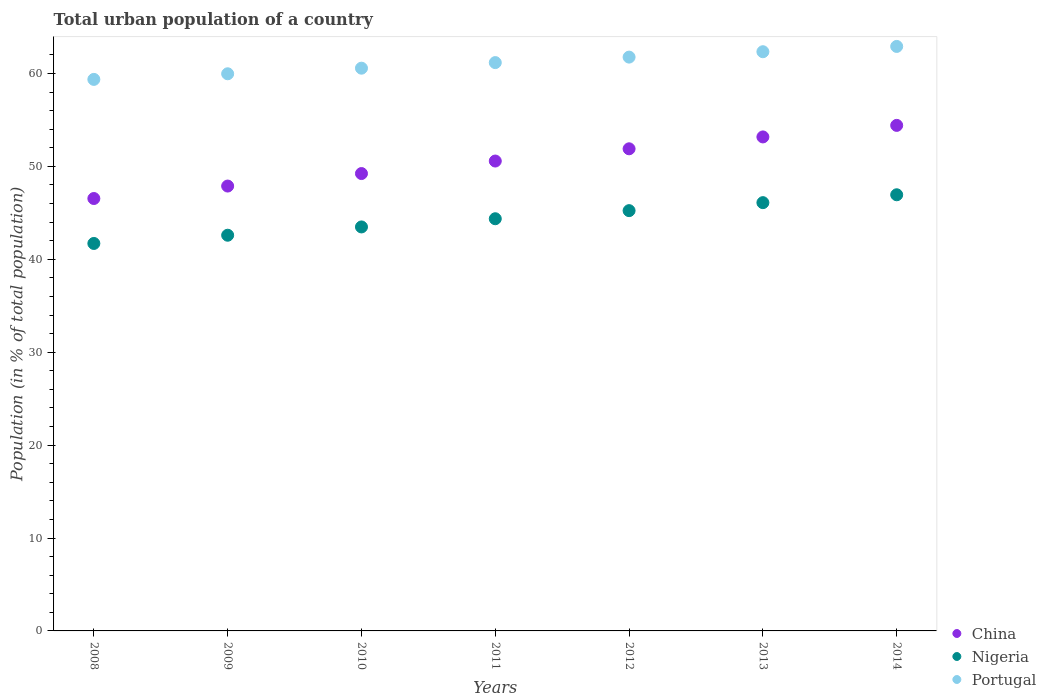How many different coloured dotlines are there?
Your answer should be compact. 3. What is the urban population in Nigeria in 2009?
Make the answer very short. 42.59. Across all years, what is the maximum urban population in China?
Offer a very short reply. 54.41. Across all years, what is the minimum urban population in Portugal?
Your response must be concise. 59.36. In which year was the urban population in Nigeria maximum?
Make the answer very short. 2014. In which year was the urban population in China minimum?
Provide a short and direct response. 2008. What is the total urban population in Portugal in the graph?
Your answer should be very brief. 428.06. What is the difference between the urban population in Portugal in 2009 and that in 2012?
Your response must be concise. -1.79. What is the difference between the urban population in Portugal in 2014 and the urban population in Nigeria in 2012?
Offer a very short reply. 17.67. What is the average urban population in China per year?
Give a very brief answer. 50.53. In the year 2008, what is the difference between the urban population in China and urban population in Portugal?
Your answer should be compact. -12.82. What is the ratio of the urban population in Nigeria in 2011 to that in 2012?
Ensure brevity in your answer.  0.98. What is the difference between the highest and the second highest urban population in Nigeria?
Make the answer very short. 0.85. What is the difference between the highest and the lowest urban population in Portugal?
Your answer should be very brief. 3.55. Is it the case that in every year, the sum of the urban population in Portugal and urban population in Nigeria  is greater than the urban population in China?
Ensure brevity in your answer.  Yes. Is the urban population in Portugal strictly less than the urban population in Nigeria over the years?
Your response must be concise. No. How many dotlines are there?
Offer a terse response. 3. How many years are there in the graph?
Keep it short and to the point. 7. What is the difference between two consecutive major ticks on the Y-axis?
Ensure brevity in your answer.  10. Are the values on the major ticks of Y-axis written in scientific E-notation?
Provide a short and direct response. No. Where does the legend appear in the graph?
Your answer should be compact. Bottom right. What is the title of the graph?
Make the answer very short. Total urban population of a country. Does "Kuwait" appear as one of the legend labels in the graph?
Your response must be concise. No. What is the label or title of the X-axis?
Offer a terse response. Years. What is the label or title of the Y-axis?
Your response must be concise. Population (in % of total population). What is the Population (in % of total population) of China in 2008?
Provide a succinct answer. 46.54. What is the Population (in % of total population) in Nigeria in 2008?
Provide a succinct answer. 41.7. What is the Population (in % of total population) of Portugal in 2008?
Keep it short and to the point. 59.36. What is the Population (in % of total population) of China in 2009?
Offer a very short reply. 47.88. What is the Population (in % of total population) in Nigeria in 2009?
Provide a succinct answer. 42.59. What is the Population (in % of total population) of Portugal in 2009?
Ensure brevity in your answer.  59.96. What is the Population (in % of total population) in China in 2010?
Your answer should be compact. 49.23. What is the Population (in % of total population) in Nigeria in 2010?
Your answer should be very brief. 43.48. What is the Population (in % of total population) of Portugal in 2010?
Your response must be concise. 60.57. What is the Population (in % of total population) in China in 2011?
Provide a short and direct response. 50.57. What is the Population (in % of total population) in Nigeria in 2011?
Offer a terse response. 44.36. What is the Population (in % of total population) in Portugal in 2011?
Your response must be concise. 61.17. What is the Population (in % of total population) of China in 2012?
Make the answer very short. 51.89. What is the Population (in % of total population) of Nigeria in 2012?
Ensure brevity in your answer.  45.23. What is the Population (in % of total population) of Portugal in 2012?
Provide a short and direct response. 61.76. What is the Population (in % of total population) of China in 2013?
Provide a short and direct response. 53.17. What is the Population (in % of total population) of Nigeria in 2013?
Give a very brief answer. 46.09. What is the Population (in % of total population) in Portugal in 2013?
Make the answer very short. 62.34. What is the Population (in % of total population) of China in 2014?
Offer a very short reply. 54.41. What is the Population (in % of total population) of Nigeria in 2014?
Offer a terse response. 46.94. What is the Population (in % of total population) in Portugal in 2014?
Provide a succinct answer. 62.91. Across all years, what is the maximum Population (in % of total population) in China?
Your answer should be compact. 54.41. Across all years, what is the maximum Population (in % of total population) of Nigeria?
Your answer should be compact. 46.94. Across all years, what is the maximum Population (in % of total population) in Portugal?
Offer a very short reply. 62.91. Across all years, what is the minimum Population (in % of total population) of China?
Your answer should be very brief. 46.54. Across all years, what is the minimum Population (in % of total population) of Nigeria?
Offer a terse response. 41.7. Across all years, what is the minimum Population (in % of total population) of Portugal?
Offer a very short reply. 59.36. What is the total Population (in % of total population) in China in the graph?
Your response must be concise. 353.69. What is the total Population (in % of total population) of Nigeria in the graph?
Your answer should be compact. 310.4. What is the total Population (in % of total population) of Portugal in the graph?
Offer a very short reply. 428.06. What is the difference between the Population (in % of total population) in China in 2008 and that in 2009?
Keep it short and to the point. -1.34. What is the difference between the Population (in % of total population) in Nigeria in 2008 and that in 2009?
Provide a succinct answer. -0.89. What is the difference between the Population (in % of total population) of Portugal in 2008 and that in 2009?
Provide a succinct answer. -0.6. What is the difference between the Population (in % of total population) of China in 2008 and that in 2010?
Provide a succinct answer. -2.69. What is the difference between the Population (in % of total population) of Nigeria in 2008 and that in 2010?
Keep it short and to the point. -1.78. What is the difference between the Population (in % of total population) of Portugal in 2008 and that in 2010?
Offer a very short reply. -1.21. What is the difference between the Population (in % of total population) in China in 2008 and that in 2011?
Offer a terse response. -4.03. What is the difference between the Population (in % of total population) in Nigeria in 2008 and that in 2011?
Offer a terse response. -2.66. What is the difference between the Population (in % of total population) in Portugal in 2008 and that in 2011?
Your answer should be compact. -1.81. What is the difference between the Population (in % of total population) of China in 2008 and that in 2012?
Provide a short and direct response. -5.35. What is the difference between the Population (in % of total population) of Nigeria in 2008 and that in 2012?
Make the answer very short. -3.53. What is the difference between the Population (in % of total population) of Portugal in 2008 and that in 2012?
Make the answer very short. -2.4. What is the difference between the Population (in % of total population) of China in 2008 and that in 2013?
Your response must be concise. -6.63. What is the difference between the Population (in % of total population) of Nigeria in 2008 and that in 2013?
Provide a succinct answer. -4.39. What is the difference between the Population (in % of total population) of Portugal in 2008 and that in 2013?
Make the answer very short. -2.98. What is the difference between the Population (in % of total population) in China in 2008 and that in 2014?
Provide a short and direct response. -7.87. What is the difference between the Population (in % of total population) in Nigeria in 2008 and that in 2014?
Provide a succinct answer. -5.24. What is the difference between the Population (in % of total population) in Portugal in 2008 and that in 2014?
Your answer should be very brief. -3.55. What is the difference between the Population (in % of total population) in China in 2009 and that in 2010?
Your response must be concise. -1.35. What is the difference between the Population (in % of total population) of Nigeria in 2009 and that in 2010?
Keep it short and to the point. -0.89. What is the difference between the Population (in % of total population) of Portugal in 2009 and that in 2010?
Provide a short and direct response. -0.6. What is the difference between the Population (in % of total population) of China in 2009 and that in 2011?
Offer a very short reply. -2.69. What is the difference between the Population (in % of total population) of Nigeria in 2009 and that in 2011?
Provide a succinct answer. -1.77. What is the difference between the Population (in % of total population) of Portugal in 2009 and that in 2011?
Offer a very short reply. -1.2. What is the difference between the Population (in % of total population) in China in 2009 and that in 2012?
Make the answer very short. -4.01. What is the difference between the Population (in % of total population) of Nigeria in 2009 and that in 2012?
Provide a succinct answer. -2.65. What is the difference between the Population (in % of total population) in Portugal in 2009 and that in 2012?
Offer a terse response. -1.79. What is the difference between the Population (in % of total population) in China in 2009 and that in 2013?
Your response must be concise. -5.29. What is the difference between the Population (in % of total population) of Nigeria in 2009 and that in 2013?
Offer a very short reply. -3.51. What is the difference between the Population (in % of total population) of Portugal in 2009 and that in 2013?
Your response must be concise. -2.37. What is the difference between the Population (in % of total population) of China in 2009 and that in 2014?
Your answer should be very brief. -6.53. What is the difference between the Population (in % of total population) in Nigeria in 2009 and that in 2014?
Make the answer very short. -4.35. What is the difference between the Population (in % of total population) of Portugal in 2009 and that in 2014?
Your answer should be compact. -2.94. What is the difference between the Population (in % of total population) of China in 2010 and that in 2011?
Your answer should be compact. -1.35. What is the difference between the Population (in % of total population) in Nigeria in 2010 and that in 2011?
Give a very brief answer. -0.88. What is the difference between the Population (in % of total population) of Portugal in 2010 and that in 2011?
Your response must be concise. -0.6. What is the difference between the Population (in % of total population) in China in 2010 and that in 2012?
Keep it short and to the point. -2.66. What is the difference between the Population (in % of total population) in Nigeria in 2010 and that in 2012?
Give a very brief answer. -1.75. What is the difference between the Population (in % of total population) in Portugal in 2010 and that in 2012?
Ensure brevity in your answer.  -1.19. What is the difference between the Population (in % of total population) in China in 2010 and that in 2013?
Your response must be concise. -3.94. What is the difference between the Population (in % of total population) in Nigeria in 2010 and that in 2013?
Make the answer very short. -2.61. What is the difference between the Population (in % of total population) of Portugal in 2010 and that in 2013?
Your response must be concise. -1.77. What is the difference between the Population (in % of total population) in China in 2010 and that in 2014?
Keep it short and to the point. -5.18. What is the difference between the Population (in % of total population) of Nigeria in 2010 and that in 2014?
Offer a terse response. -3.46. What is the difference between the Population (in % of total population) of Portugal in 2010 and that in 2014?
Provide a short and direct response. -2.34. What is the difference between the Population (in % of total population) in China in 2011 and that in 2012?
Your response must be concise. -1.32. What is the difference between the Population (in % of total population) in Nigeria in 2011 and that in 2012?
Make the answer very short. -0.87. What is the difference between the Population (in % of total population) of Portugal in 2011 and that in 2012?
Provide a succinct answer. -0.59. What is the difference between the Population (in % of total population) of China in 2011 and that in 2013?
Give a very brief answer. -2.6. What is the difference between the Population (in % of total population) in Nigeria in 2011 and that in 2013?
Ensure brevity in your answer.  -1.73. What is the difference between the Population (in % of total population) in Portugal in 2011 and that in 2013?
Your answer should be compact. -1.17. What is the difference between the Population (in % of total population) of China in 2011 and that in 2014?
Your answer should be compact. -3.84. What is the difference between the Population (in % of total population) in Nigeria in 2011 and that in 2014?
Offer a terse response. -2.58. What is the difference between the Population (in % of total population) in Portugal in 2011 and that in 2014?
Provide a succinct answer. -1.74. What is the difference between the Population (in % of total population) of China in 2012 and that in 2013?
Your response must be concise. -1.28. What is the difference between the Population (in % of total population) in Nigeria in 2012 and that in 2013?
Provide a succinct answer. -0.86. What is the difference between the Population (in % of total population) in Portugal in 2012 and that in 2013?
Your response must be concise. -0.58. What is the difference between the Population (in % of total population) of China in 2012 and that in 2014?
Make the answer very short. -2.52. What is the difference between the Population (in % of total population) in Nigeria in 2012 and that in 2014?
Ensure brevity in your answer.  -1.71. What is the difference between the Population (in % of total population) of Portugal in 2012 and that in 2014?
Your answer should be compact. -1.15. What is the difference between the Population (in % of total population) in China in 2013 and that in 2014?
Give a very brief answer. -1.24. What is the difference between the Population (in % of total population) in Nigeria in 2013 and that in 2014?
Give a very brief answer. -0.85. What is the difference between the Population (in % of total population) in Portugal in 2013 and that in 2014?
Offer a very short reply. -0.57. What is the difference between the Population (in % of total population) in China in 2008 and the Population (in % of total population) in Nigeria in 2009?
Provide a succinct answer. 3.95. What is the difference between the Population (in % of total population) of China in 2008 and the Population (in % of total population) of Portugal in 2009?
Offer a terse response. -13.43. What is the difference between the Population (in % of total population) of Nigeria in 2008 and the Population (in % of total population) of Portugal in 2009?
Your answer should be compact. -18.26. What is the difference between the Population (in % of total population) in China in 2008 and the Population (in % of total population) in Nigeria in 2010?
Offer a very short reply. 3.06. What is the difference between the Population (in % of total population) of China in 2008 and the Population (in % of total population) of Portugal in 2010?
Keep it short and to the point. -14.03. What is the difference between the Population (in % of total population) of Nigeria in 2008 and the Population (in % of total population) of Portugal in 2010?
Make the answer very short. -18.86. What is the difference between the Population (in % of total population) of China in 2008 and the Population (in % of total population) of Nigeria in 2011?
Your answer should be compact. 2.18. What is the difference between the Population (in % of total population) in China in 2008 and the Population (in % of total population) in Portugal in 2011?
Ensure brevity in your answer.  -14.63. What is the difference between the Population (in % of total population) of Nigeria in 2008 and the Population (in % of total population) of Portugal in 2011?
Give a very brief answer. -19.46. What is the difference between the Population (in % of total population) of China in 2008 and the Population (in % of total population) of Nigeria in 2012?
Keep it short and to the point. 1.3. What is the difference between the Population (in % of total population) of China in 2008 and the Population (in % of total population) of Portugal in 2012?
Offer a very short reply. -15.22. What is the difference between the Population (in % of total population) in Nigeria in 2008 and the Population (in % of total population) in Portugal in 2012?
Offer a very short reply. -20.06. What is the difference between the Population (in % of total population) in China in 2008 and the Population (in % of total population) in Nigeria in 2013?
Make the answer very short. 0.45. What is the difference between the Population (in % of total population) of China in 2008 and the Population (in % of total population) of Portugal in 2013?
Make the answer very short. -15.8. What is the difference between the Population (in % of total population) in Nigeria in 2008 and the Population (in % of total population) in Portugal in 2013?
Keep it short and to the point. -20.64. What is the difference between the Population (in % of total population) in China in 2008 and the Population (in % of total population) in Nigeria in 2014?
Provide a short and direct response. -0.4. What is the difference between the Population (in % of total population) of China in 2008 and the Population (in % of total population) of Portugal in 2014?
Provide a short and direct response. -16.37. What is the difference between the Population (in % of total population) in Nigeria in 2008 and the Population (in % of total population) in Portugal in 2014?
Offer a terse response. -21.21. What is the difference between the Population (in % of total population) in China in 2009 and the Population (in % of total population) in Portugal in 2010?
Offer a very short reply. -12.69. What is the difference between the Population (in % of total population) of Nigeria in 2009 and the Population (in % of total population) of Portugal in 2010?
Offer a very short reply. -17.98. What is the difference between the Population (in % of total population) of China in 2009 and the Population (in % of total population) of Nigeria in 2011?
Offer a terse response. 3.52. What is the difference between the Population (in % of total population) of China in 2009 and the Population (in % of total population) of Portugal in 2011?
Your answer should be very brief. -13.29. What is the difference between the Population (in % of total population) of Nigeria in 2009 and the Population (in % of total population) of Portugal in 2011?
Your answer should be compact. -18.58. What is the difference between the Population (in % of total population) of China in 2009 and the Population (in % of total population) of Nigeria in 2012?
Provide a succinct answer. 2.65. What is the difference between the Population (in % of total population) of China in 2009 and the Population (in % of total population) of Portugal in 2012?
Your answer should be compact. -13.88. What is the difference between the Population (in % of total population) of Nigeria in 2009 and the Population (in % of total population) of Portugal in 2012?
Give a very brief answer. -19.17. What is the difference between the Population (in % of total population) of China in 2009 and the Population (in % of total population) of Nigeria in 2013?
Provide a short and direct response. 1.79. What is the difference between the Population (in % of total population) of China in 2009 and the Population (in % of total population) of Portugal in 2013?
Provide a succinct answer. -14.46. What is the difference between the Population (in % of total population) of Nigeria in 2009 and the Population (in % of total population) of Portugal in 2013?
Your answer should be compact. -19.75. What is the difference between the Population (in % of total population) of China in 2009 and the Population (in % of total population) of Nigeria in 2014?
Your response must be concise. 0.94. What is the difference between the Population (in % of total population) in China in 2009 and the Population (in % of total population) in Portugal in 2014?
Your answer should be compact. -15.03. What is the difference between the Population (in % of total population) in Nigeria in 2009 and the Population (in % of total population) in Portugal in 2014?
Offer a very short reply. -20.32. What is the difference between the Population (in % of total population) in China in 2010 and the Population (in % of total population) in Nigeria in 2011?
Your response must be concise. 4.86. What is the difference between the Population (in % of total population) of China in 2010 and the Population (in % of total population) of Portugal in 2011?
Offer a terse response. -11.94. What is the difference between the Population (in % of total population) in Nigeria in 2010 and the Population (in % of total population) in Portugal in 2011?
Your answer should be very brief. -17.69. What is the difference between the Population (in % of total population) in China in 2010 and the Population (in % of total population) in Nigeria in 2012?
Your answer should be compact. 3.99. What is the difference between the Population (in % of total population) of China in 2010 and the Population (in % of total population) of Portugal in 2012?
Offer a terse response. -12.53. What is the difference between the Population (in % of total population) in Nigeria in 2010 and the Population (in % of total population) in Portugal in 2012?
Your response must be concise. -18.28. What is the difference between the Population (in % of total population) of China in 2010 and the Population (in % of total population) of Nigeria in 2013?
Your answer should be very brief. 3.13. What is the difference between the Population (in % of total population) of China in 2010 and the Population (in % of total population) of Portugal in 2013?
Offer a terse response. -13.11. What is the difference between the Population (in % of total population) of Nigeria in 2010 and the Population (in % of total population) of Portugal in 2013?
Provide a short and direct response. -18.86. What is the difference between the Population (in % of total population) of China in 2010 and the Population (in % of total population) of Nigeria in 2014?
Ensure brevity in your answer.  2.28. What is the difference between the Population (in % of total population) in China in 2010 and the Population (in % of total population) in Portugal in 2014?
Offer a terse response. -13.68. What is the difference between the Population (in % of total population) of Nigeria in 2010 and the Population (in % of total population) of Portugal in 2014?
Provide a short and direct response. -19.43. What is the difference between the Population (in % of total population) in China in 2011 and the Population (in % of total population) in Nigeria in 2012?
Provide a succinct answer. 5.34. What is the difference between the Population (in % of total population) in China in 2011 and the Population (in % of total population) in Portugal in 2012?
Keep it short and to the point. -11.19. What is the difference between the Population (in % of total population) in Nigeria in 2011 and the Population (in % of total population) in Portugal in 2012?
Ensure brevity in your answer.  -17.4. What is the difference between the Population (in % of total population) in China in 2011 and the Population (in % of total population) in Nigeria in 2013?
Provide a succinct answer. 4.48. What is the difference between the Population (in % of total population) in China in 2011 and the Population (in % of total population) in Portugal in 2013?
Offer a terse response. -11.77. What is the difference between the Population (in % of total population) in Nigeria in 2011 and the Population (in % of total population) in Portugal in 2013?
Keep it short and to the point. -17.98. What is the difference between the Population (in % of total population) in China in 2011 and the Population (in % of total population) in Nigeria in 2014?
Make the answer very short. 3.63. What is the difference between the Population (in % of total population) of China in 2011 and the Population (in % of total population) of Portugal in 2014?
Give a very brief answer. -12.34. What is the difference between the Population (in % of total population) in Nigeria in 2011 and the Population (in % of total population) in Portugal in 2014?
Ensure brevity in your answer.  -18.55. What is the difference between the Population (in % of total population) of China in 2012 and the Population (in % of total population) of Nigeria in 2013?
Give a very brief answer. 5.79. What is the difference between the Population (in % of total population) in China in 2012 and the Population (in % of total population) in Portugal in 2013?
Your answer should be very brief. -10.45. What is the difference between the Population (in % of total population) of Nigeria in 2012 and the Population (in % of total population) of Portugal in 2013?
Provide a short and direct response. -17.1. What is the difference between the Population (in % of total population) of China in 2012 and the Population (in % of total population) of Nigeria in 2014?
Give a very brief answer. 4.95. What is the difference between the Population (in % of total population) in China in 2012 and the Population (in % of total population) in Portugal in 2014?
Your response must be concise. -11.02. What is the difference between the Population (in % of total population) in Nigeria in 2012 and the Population (in % of total population) in Portugal in 2014?
Offer a very short reply. -17.67. What is the difference between the Population (in % of total population) of China in 2013 and the Population (in % of total population) of Nigeria in 2014?
Offer a terse response. 6.23. What is the difference between the Population (in % of total population) in China in 2013 and the Population (in % of total population) in Portugal in 2014?
Your answer should be very brief. -9.74. What is the difference between the Population (in % of total population) of Nigeria in 2013 and the Population (in % of total population) of Portugal in 2014?
Offer a very short reply. -16.81. What is the average Population (in % of total population) of China per year?
Give a very brief answer. 50.53. What is the average Population (in % of total population) of Nigeria per year?
Offer a very short reply. 44.34. What is the average Population (in % of total population) in Portugal per year?
Give a very brief answer. 61.15. In the year 2008, what is the difference between the Population (in % of total population) in China and Population (in % of total population) in Nigeria?
Your answer should be compact. 4.84. In the year 2008, what is the difference between the Population (in % of total population) in China and Population (in % of total population) in Portugal?
Offer a terse response. -12.82. In the year 2008, what is the difference between the Population (in % of total population) of Nigeria and Population (in % of total population) of Portugal?
Provide a succinct answer. -17.66. In the year 2009, what is the difference between the Population (in % of total population) of China and Population (in % of total population) of Nigeria?
Keep it short and to the point. 5.29. In the year 2009, what is the difference between the Population (in % of total population) of China and Population (in % of total population) of Portugal?
Your answer should be very brief. -12.08. In the year 2009, what is the difference between the Population (in % of total population) in Nigeria and Population (in % of total population) in Portugal?
Provide a succinct answer. -17.38. In the year 2010, what is the difference between the Population (in % of total population) of China and Population (in % of total population) of Nigeria?
Provide a short and direct response. 5.75. In the year 2010, what is the difference between the Population (in % of total population) in China and Population (in % of total population) in Portugal?
Keep it short and to the point. -11.34. In the year 2010, what is the difference between the Population (in % of total population) in Nigeria and Population (in % of total population) in Portugal?
Offer a terse response. -17.09. In the year 2011, what is the difference between the Population (in % of total population) in China and Population (in % of total population) in Nigeria?
Keep it short and to the point. 6.21. In the year 2011, what is the difference between the Population (in % of total population) in China and Population (in % of total population) in Portugal?
Ensure brevity in your answer.  -10.59. In the year 2011, what is the difference between the Population (in % of total population) in Nigeria and Population (in % of total population) in Portugal?
Make the answer very short. -16.8. In the year 2012, what is the difference between the Population (in % of total population) in China and Population (in % of total population) in Nigeria?
Ensure brevity in your answer.  6.66. In the year 2012, what is the difference between the Population (in % of total population) in China and Population (in % of total population) in Portugal?
Provide a short and direct response. -9.87. In the year 2012, what is the difference between the Population (in % of total population) of Nigeria and Population (in % of total population) of Portugal?
Your answer should be very brief. -16.52. In the year 2013, what is the difference between the Population (in % of total population) of China and Population (in % of total population) of Nigeria?
Offer a terse response. 7.07. In the year 2013, what is the difference between the Population (in % of total population) in China and Population (in % of total population) in Portugal?
Your answer should be very brief. -9.17. In the year 2013, what is the difference between the Population (in % of total population) in Nigeria and Population (in % of total population) in Portugal?
Provide a short and direct response. -16.24. In the year 2014, what is the difference between the Population (in % of total population) in China and Population (in % of total population) in Nigeria?
Your answer should be very brief. 7.47. In the year 2014, what is the difference between the Population (in % of total population) in China and Population (in % of total population) in Portugal?
Make the answer very short. -8.5. In the year 2014, what is the difference between the Population (in % of total population) in Nigeria and Population (in % of total population) in Portugal?
Provide a short and direct response. -15.97. What is the ratio of the Population (in % of total population) of Nigeria in 2008 to that in 2009?
Your answer should be compact. 0.98. What is the ratio of the Population (in % of total population) of China in 2008 to that in 2010?
Give a very brief answer. 0.95. What is the ratio of the Population (in % of total population) in Nigeria in 2008 to that in 2010?
Your response must be concise. 0.96. What is the ratio of the Population (in % of total population) of Portugal in 2008 to that in 2010?
Keep it short and to the point. 0.98. What is the ratio of the Population (in % of total population) in China in 2008 to that in 2011?
Your response must be concise. 0.92. What is the ratio of the Population (in % of total population) of Nigeria in 2008 to that in 2011?
Provide a succinct answer. 0.94. What is the ratio of the Population (in % of total population) in Portugal in 2008 to that in 2011?
Offer a very short reply. 0.97. What is the ratio of the Population (in % of total population) of China in 2008 to that in 2012?
Offer a very short reply. 0.9. What is the ratio of the Population (in % of total population) of Nigeria in 2008 to that in 2012?
Provide a succinct answer. 0.92. What is the ratio of the Population (in % of total population) in Portugal in 2008 to that in 2012?
Keep it short and to the point. 0.96. What is the ratio of the Population (in % of total population) of China in 2008 to that in 2013?
Provide a succinct answer. 0.88. What is the ratio of the Population (in % of total population) of Nigeria in 2008 to that in 2013?
Offer a very short reply. 0.9. What is the ratio of the Population (in % of total population) of Portugal in 2008 to that in 2013?
Give a very brief answer. 0.95. What is the ratio of the Population (in % of total population) of China in 2008 to that in 2014?
Provide a succinct answer. 0.86. What is the ratio of the Population (in % of total population) of Nigeria in 2008 to that in 2014?
Offer a terse response. 0.89. What is the ratio of the Population (in % of total population) of Portugal in 2008 to that in 2014?
Provide a short and direct response. 0.94. What is the ratio of the Population (in % of total population) of China in 2009 to that in 2010?
Offer a very short reply. 0.97. What is the ratio of the Population (in % of total population) in Nigeria in 2009 to that in 2010?
Your answer should be very brief. 0.98. What is the ratio of the Population (in % of total population) in Portugal in 2009 to that in 2010?
Your answer should be compact. 0.99. What is the ratio of the Population (in % of total population) in China in 2009 to that in 2011?
Your response must be concise. 0.95. What is the ratio of the Population (in % of total population) of Nigeria in 2009 to that in 2011?
Keep it short and to the point. 0.96. What is the ratio of the Population (in % of total population) of Portugal in 2009 to that in 2011?
Offer a very short reply. 0.98. What is the ratio of the Population (in % of total population) of China in 2009 to that in 2012?
Make the answer very short. 0.92. What is the ratio of the Population (in % of total population) in Nigeria in 2009 to that in 2012?
Provide a succinct answer. 0.94. What is the ratio of the Population (in % of total population) in Portugal in 2009 to that in 2012?
Keep it short and to the point. 0.97. What is the ratio of the Population (in % of total population) of China in 2009 to that in 2013?
Ensure brevity in your answer.  0.9. What is the ratio of the Population (in % of total population) of Nigeria in 2009 to that in 2013?
Ensure brevity in your answer.  0.92. What is the ratio of the Population (in % of total population) in Portugal in 2009 to that in 2013?
Offer a very short reply. 0.96. What is the ratio of the Population (in % of total population) of China in 2009 to that in 2014?
Provide a short and direct response. 0.88. What is the ratio of the Population (in % of total population) in Nigeria in 2009 to that in 2014?
Provide a succinct answer. 0.91. What is the ratio of the Population (in % of total population) in Portugal in 2009 to that in 2014?
Keep it short and to the point. 0.95. What is the ratio of the Population (in % of total population) of China in 2010 to that in 2011?
Offer a terse response. 0.97. What is the ratio of the Population (in % of total population) of Nigeria in 2010 to that in 2011?
Give a very brief answer. 0.98. What is the ratio of the Population (in % of total population) in Portugal in 2010 to that in 2011?
Ensure brevity in your answer.  0.99. What is the ratio of the Population (in % of total population) of China in 2010 to that in 2012?
Ensure brevity in your answer.  0.95. What is the ratio of the Population (in % of total population) in Nigeria in 2010 to that in 2012?
Make the answer very short. 0.96. What is the ratio of the Population (in % of total population) of Portugal in 2010 to that in 2012?
Make the answer very short. 0.98. What is the ratio of the Population (in % of total population) in China in 2010 to that in 2013?
Your answer should be compact. 0.93. What is the ratio of the Population (in % of total population) in Nigeria in 2010 to that in 2013?
Your answer should be very brief. 0.94. What is the ratio of the Population (in % of total population) in Portugal in 2010 to that in 2013?
Make the answer very short. 0.97. What is the ratio of the Population (in % of total population) in China in 2010 to that in 2014?
Offer a very short reply. 0.9. What is the ratio of the Population (in % of total population) in Nigeria in 2010 to that in 2014?
Ensure brevity in your answer.  0.93. What is the ratio of the Population (in % of total population) in Portugal in 2010 to that in 2014?
Keep it short and to the point. 0.96. What is the ratio of the Population (in % of total population) of China in 2011 to that in 2012?
Offer a very short reply. 0.97. What is the ratio of the Population (in % of total population) of Nigeria in 2011 to that in 2012?
Ensure brevity in your answer.  0.98. What is the ratio of the Population (in % of total population) of China in 2011 to that in 2013?
Ensure brevity in your answer.  0.95. What is the ratio of the Population (in % of total population) of Nigeria in 2011 to that in 2013?
Your response must be concise. 0.96. What is the ratio of the Population (in % of total population) in Portugal in 2011 to that in 2013?
Make the answer very short. 0.98. What is the ratio of the Population (in % of total population) of China in 2011 to that in 2014?
Make the answer very short. 0.93. What is the ratio of the Population (in % of total population) in Nigeria in 2011 to that in 2014?
Offer a very short reply. 0.94. What is the ratio of the Population (in % of total population) of Portugal in 2011 to that in 2014?
Your answer should be compact. 0.97. What is the ratio of the Population (in % of total population) in China in 2012 to that in 2013?
Your response must be concise. 0.98. What is the ratio of the Population (in % of total population) of Nigeria in 2012 to that in 2013?
Provide a short and direct response. 0.98. What is the ratio of the Population (in % of total population) of China in 2012 to that in 2014?
Make the answer very short. 0.95. What is the ratio of the Population (in % of total population) of Nigeria in 2012 to that in 2014?
Offer a terse response. 0.96. What is the ratio of the Population (in % of total population) in Portugal in 2012 to that in 2014?
Offer a terse response. 0.98. What is the ratio of the Population (in % of total population) in China in 2013 to that in 2014?
Provide a short and direct response. 0.98. What is the ratio of the Population (in % of total population) in Nigeria in 2013 to that in 2014?
Provide a short and direct response. 0.98. What is the ratio of the Population (in % of total population) of Portugal in 2013 to that in 2014?
Your response must be concise. 0.99. What is the difference between the highest and the second highest Population (in % of total population) of China?
Give a very brief answer. 1.24. What is the difference between the highest and the second highest Population (in % of total population) in Nigeria?
Keep it short and to the point. 0.85. What is the difference between the highest and the second highest Population (in % of total population) of Portugal?
Provide a succinct answer. 0.57. What is the difference between the highest and the lowest Population (in % of total population) of China?
Provide a succinct answer. 7.87. What is the difference between the highest and the lowest Population (in % of total population) of Nigeria?
Provide a short and direct response. 5.24. What is the difference between the highest and the lowest Population (in % of total population) in Portugal?
Provide a short and direct response. 3.55. 